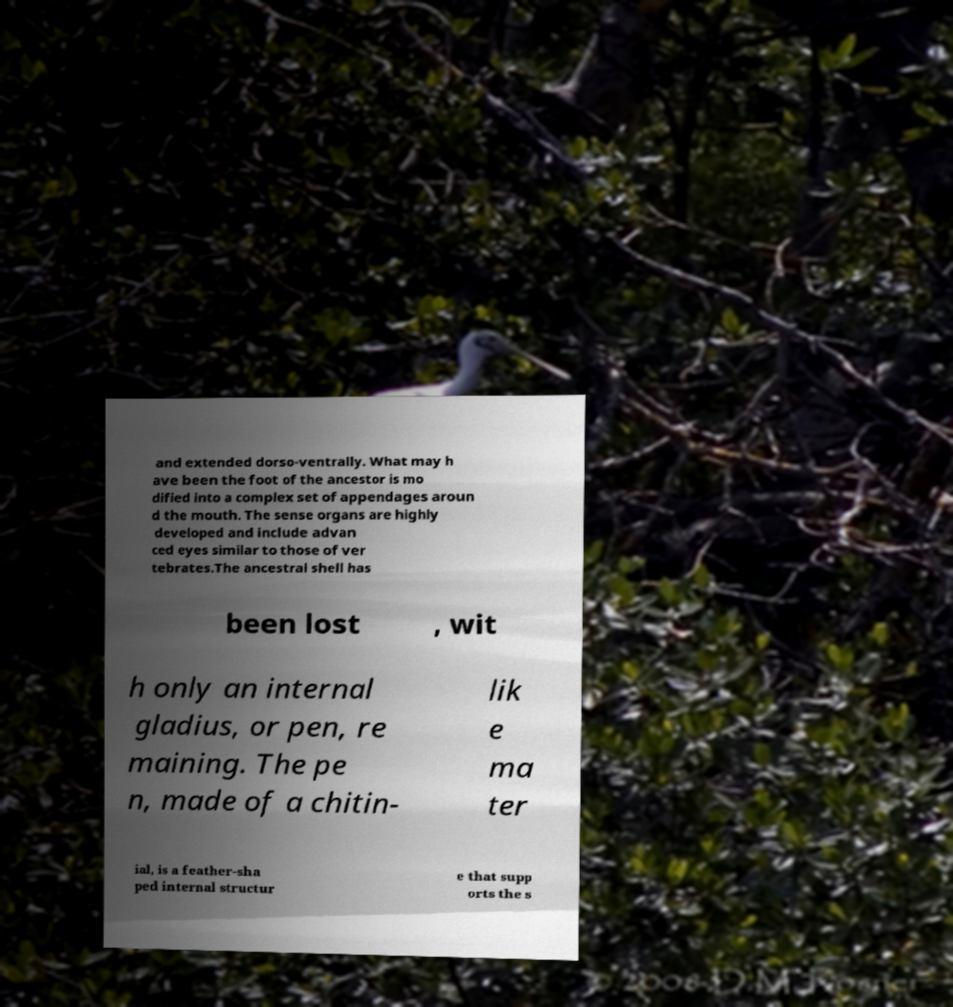Could you extract and type out the text from this image? and extended dorso-ventrally. What may h ave been the foot of the ancestor is mo dified into a complex set of appendages aroun d the mouth. The sense organs are highly developed and include advan ced eyes similar to those of ver tebrates.The ancestral shell has been lost , wit h only an internal gladius, or pen, re maining. The pe n, made of a chitin- lik e ma ter ial, is a feather-sha ped internal structur e that supp orts the s 